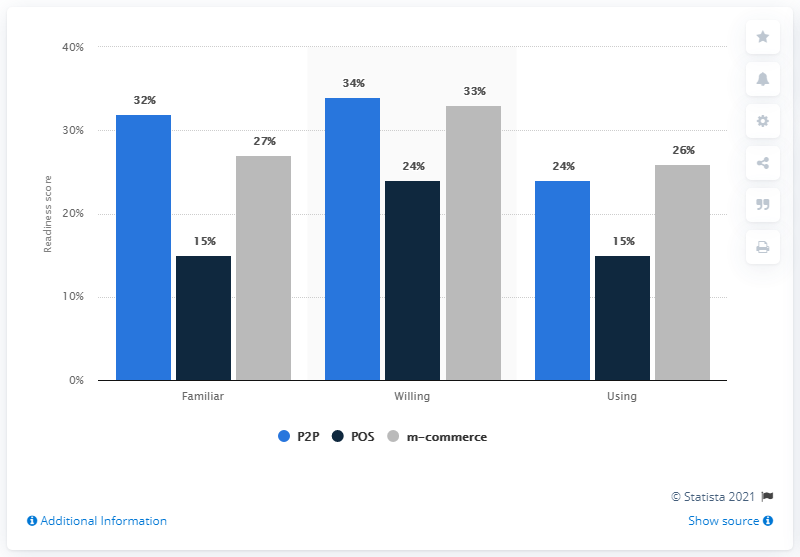Indicate a few pertinent items in this graphic. The highest percentage value in the dark blue bar is 24%. The average of the dark blue bar is 18. 